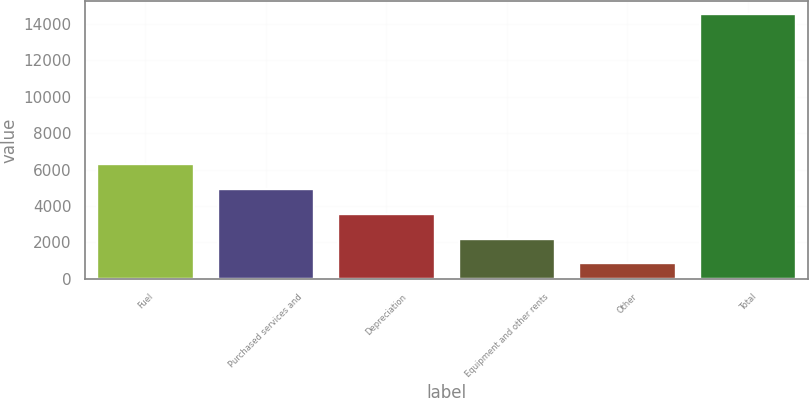Convert chart to OTSL. <chart><loc_0><loc_0><loc_500><loc_500><bar_chart><fcel>Fuel<fcel>Purchased services and<fcel>Depreciation<fcel>Equipment and other rents<fcel>Other<fcel>Total<nl><fcel>6316.2<fcel>4949.4<fcel>3582.6<fcel>2215.8<fcel>849<fcel>14517<nl></chart> 